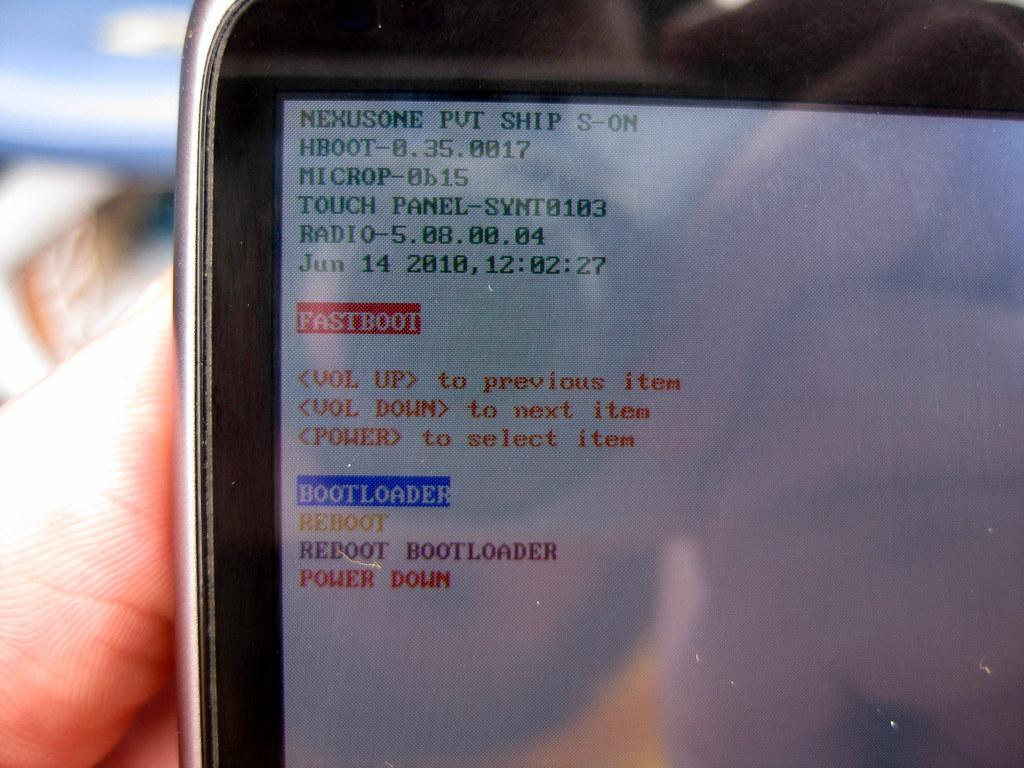<image>
Create a compact narrative representing the image presented. A person holding a device with the words Fastboot in red and the word Bootloader in blue 